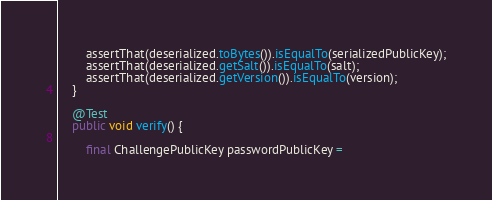Convert code to text. <code><loc_0><loc_0><loc_500><loc_500><_Java_>        assertThat(deserialized.toBytes()).isEqualTo(serializedPublicKey);
        assertThat(deserialized.getSalt()).isEqualTo(salt);
        assertThat(deserialized.getVersion()).isEqualTo(version);
    }

    @Test
    public void verify() {

        final ChallengePublicKey passwordPublicKey =</code> 